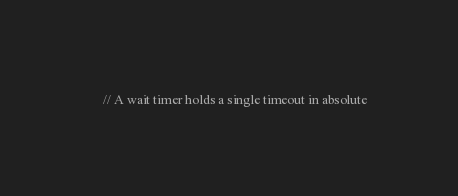<code> <loc_0><loc_0><loc_500><loc_500><_C_>
    // A wait timer holds a single timeout in absolute</code> 